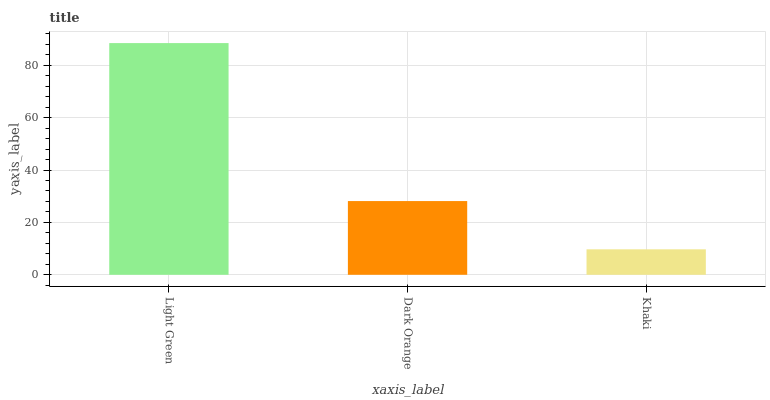Is Khaki the minimum?
Answer yes or no. Yes. Is Light Green the maximum?
Answer yes or no. Yes. Is Dark Orange the minimum?
Answer yes or no. No. Is Dark Orange the maximum?
Answer yes or no. No. Is Light Green greater than Dark Orange?
Answer yes or no. Yes. Is Dark Orange less than Light Green?
Answer yes or no. Yes. Is Dark Orange greater than Light Green?
Answer yes or no. No. Is Light Green less than Dark Orange?
Answer yes or no. No. Is Dark Orange the high median?
Answer yes or no. Yes. Is Dark Orange the low median?
Answer yes or no. Yes. Is Khaki the high median?
Answer yes or no. No. Is Khaki the low median?
Answer yes or no. No. 